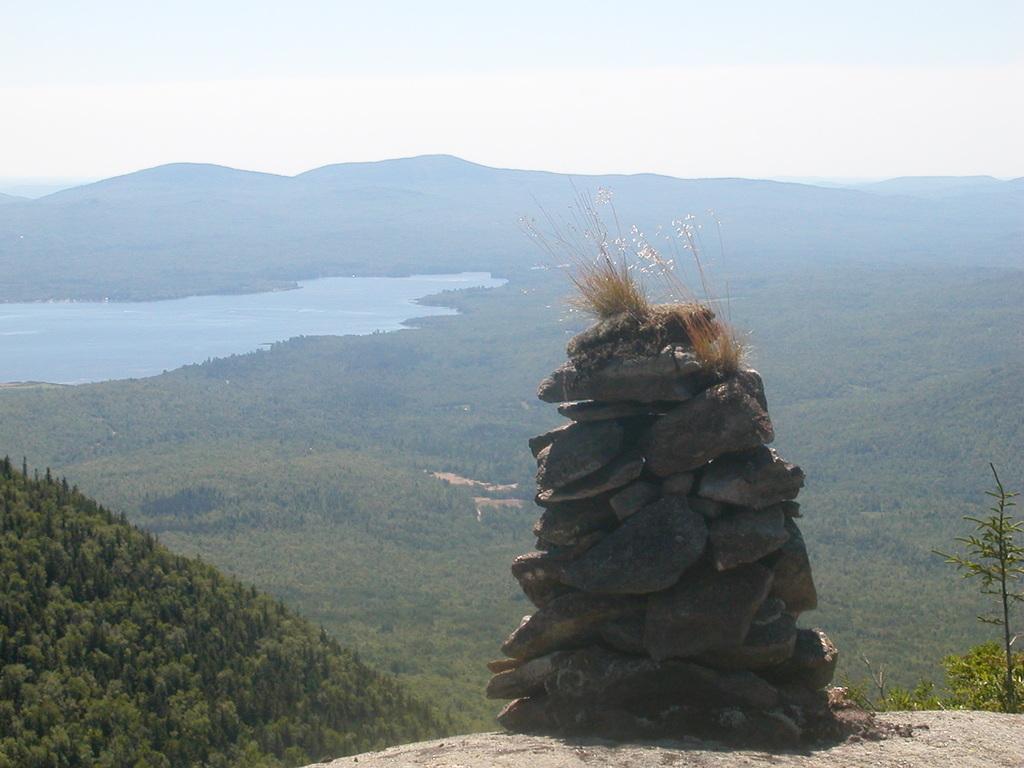Could you give a brief overview of what you see in this image? In this picture there are mountains and trees. In the foreground there are stones and there are plants. At the top there is sky. At the bottom there is water. 